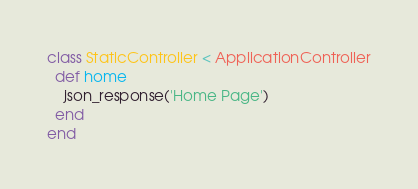Convert code to text. <code><loc_0><loc_0><loc_500><loc_500><_Ruby_>class StaticController < ApplicationController
  def home
    json_response('Home Page')
  end
end
</code> 